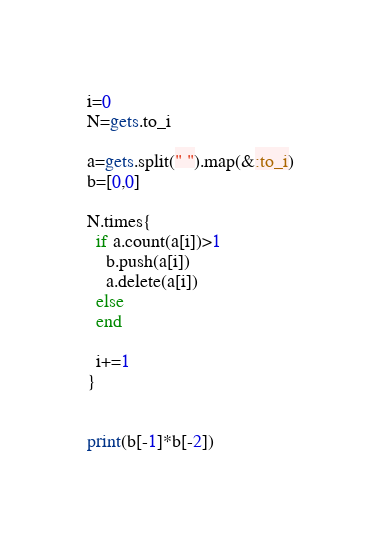Convert code to text. <code><loc_0><loc_0><loc_500><loc_500><_Ruby_>i=0
N=gets.to_i

a=gets.split(" ").map(&:to_i)
b=[0,0]

N.times{
  if a.count(a[i])>1
    b.push(a[i])
    a.delete(a[i])
  else
  end
  
  i+=1
}


print(b[-1]*b[-2])
</code> 